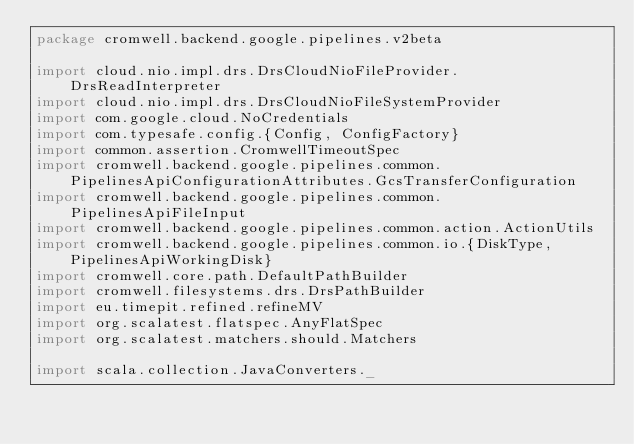Convert code to text. <code><loc_0><loc_0><loc_500><loc_500><_Scala_>package cromwell.backend.google.pipelines.v2beta

import cloud.nio.impl.drs.DrsCloudNioFileProvider.DrsReadInterpreter
import cloud.nio.impl.drs.DrsCloudNioFileSystemProvider
import com.google.cloud.NoCredentials
import com.typesafe.config.{Config, ConfigFactory}
import common.assertion.CromwellTimeoutSpec
import cromwell.backend.google.pipelines.common.PipelinesApiConfigurationAttributes.GcsTransferConfiguration
import cromwell.backend.google.pipelines.common.PipelinesApiFileInput
import cromwell.backend.google.pipelines.common.action.ActionUtils
import cromwell.backend.google.pipelines.common.io.{DiskType, PipelinesApiWorkingDisk}
import cromwell.core.path.DefaultPathBuilder
import cromwell.filesystems.drs.DrsPathBuilder
import eu.timepit.refined.refineMV
import org.scalatest.flatspec.AnyFlatSpec
import org.scalatest.matchers.should.Matchers

import scala.collection.JavaConverters._
</code> 